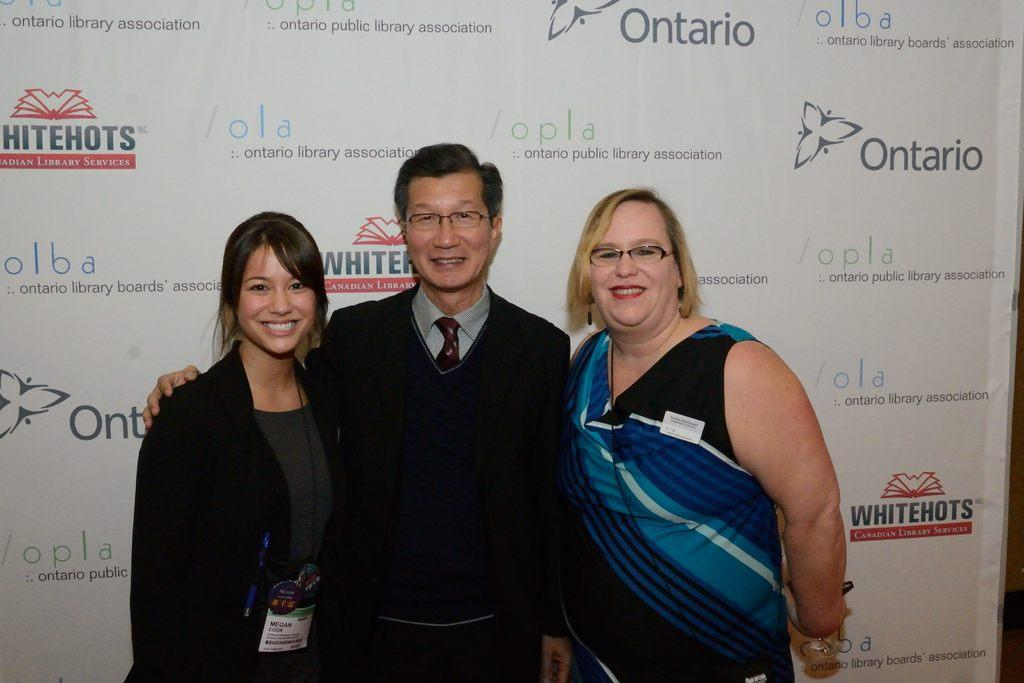<image>
Share a concise interpretation of the image provided. Two Asians and a Caucasian woman are posing for a photo shoot in front of a back drop that says Ontario. 